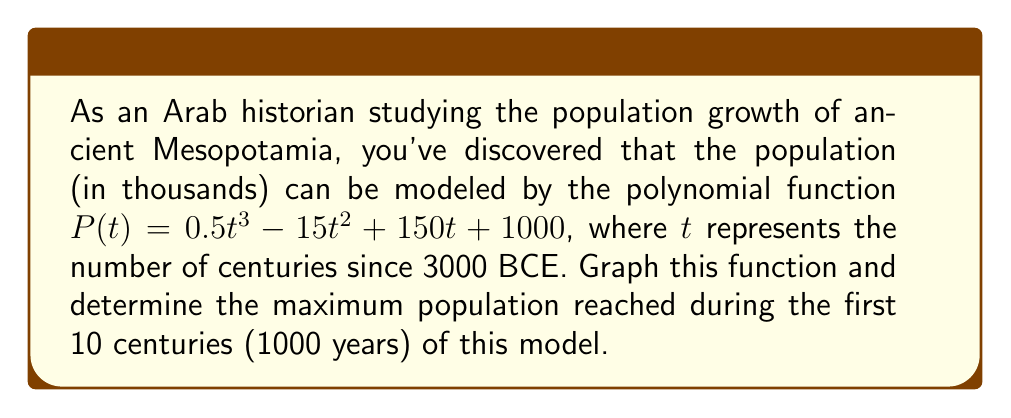What is the answer to this math problem? To solve this problem, we'll follow these steps:

1) First, let's graph the polynomial function $P(t) = 0.5t^3 - 15t^2 + 150t + 1000$ for $t$ from 0 to 10.

[asy]
import graph;
size(200,200);
real f(real x) {return 0.5x^3 - 15x^2 + 150x + 1000;}
draw(graph(f,0,10),blue);
xaxis("t (centuries)",arrow=Arrow());
yaxis("P(t) (thousands)",arrow=Arrow());
label("P(t)",(-1,f(0)),W);
[/asy]

2) To find the maximum population, we need to find the highest point on this curve within the domain $[0,10]$.

3) Mathematically, we can find this by taking the derivative of $P(t)$, setting it to zero, and solving for $t$:

   $P'(t) = 1.5t^2 - 30t + 150$
   
   $1.5t^2 - 30t + 150 = 0$

4) This is a quadratic equation. We can solve it using the quadratic formula:

   $t = \frac{-b \pm \sqrt{b^2 - 4ac}}{2a}$

   Where $a=1.5$, $b=-30$, and $c=150$

5) Solving this:

   $t = \frac{30 \pm \sqrt{900 - 900}}{3} = \frac{30 \pm 0}{3} = 10$

6) This critical point $t=10$ is within our domain $[0,10]$.

7) To confirm it's a maximum, we can check the second derivative:

   $P''(t) = 3t - 30$
   $P''(10) = 30 - 30 = 0$

   Since $P''(10) = 0$, we need to check values on either side:
   $P''(9) < 0$ and $P''(11) > 0$, confirming a maximum at $t=10$.

8) The maximum population is therefore:

   $P(10) = 0.5(10)^3 - 15(10)^2 + 150(10) + 1000 = 2500$
Answer: 2,500,000 people 